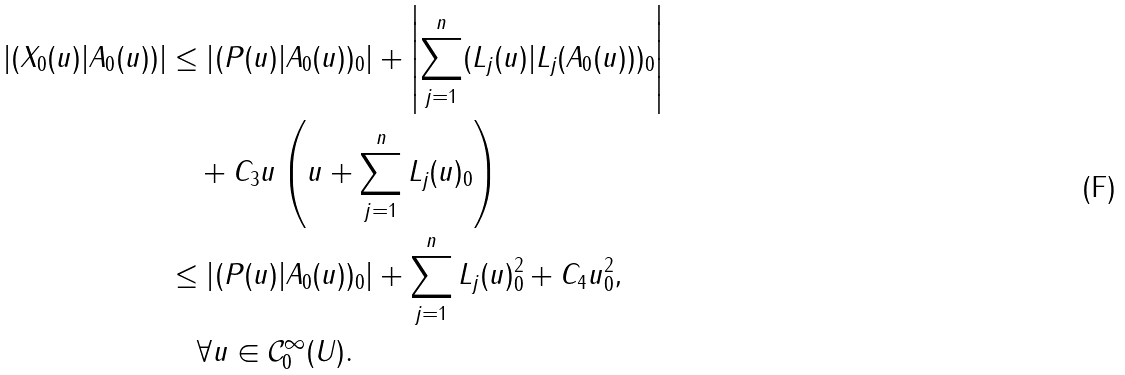Convert formula to latex. <formula><loc_0><loc_0><loc_500><loc_500>\left | ( X _ { 0 } ( u ) | A _ { 0 } ( u ) ) \right | & \leq \left | ( P ( u ) | A _ { 0 } ( u ) ) _ { 0 } \right | + \left | \sum _ { j = 1 } ^ { n } ( L _ { j } ( u ) | L _ { j } ( A _ { 0 } ( u ) ) ) _ { 0 } \right | \\ & \quad + C _ { 3 } \| u \| \left ( \| u \| + \sum _ { j = 1 } ^ { n } \| L _ { j } ( u ) \| _ { 0 } \right ) \\ & \leq \left | ( P ( u ) | A _ { 0 } ( u ) ) _ { 0 } \right | + \sum _ { j = 1 } ^ { n } \| L _ { j } ( u ) \| ^ { 2 } _ { 0 } + C _ { 4 } \| u \| _ { 0 } ^ { 2 } , \\ & \quad \forall { u } \in \mathcal { C } ^ { \infty } _ { 0 } ( U ) .</formula> 